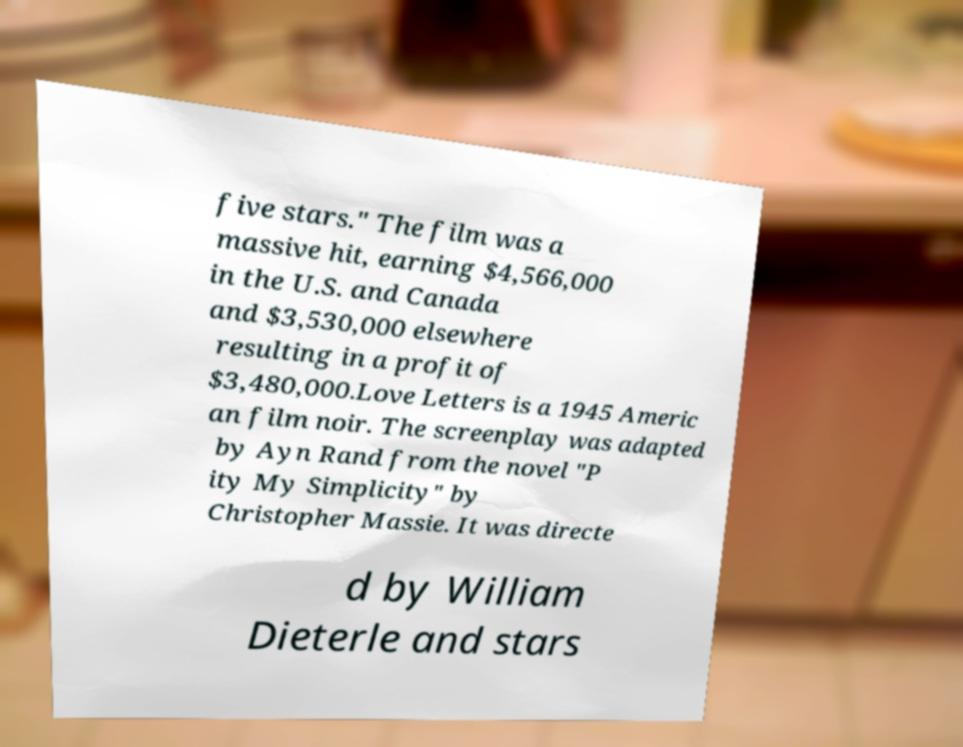Could you assist in decoding the text presented in this image and type it out clearly? five stars." The film was a massive hit, earning $4,566,000 in the U.S. and Canada and $3,530,000 elsewhere resulting in a profit of $3,480,000.Love Letters is a 1945 Americ an film noir. The screenplay was adapted by Ayn Rand from the novel "P ity My Simplicity" by Christopher Massie. It was directe d by William Dieterle and stars 